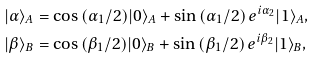Convert formula to latex. <formula><loc_0><loc_0><loc_500><loc_500>& | \alpha \rangle _ { A } = \cos { ( \alpha _ { 1 } / 2 ) } | 0 \rangle _ { A } + \sin { ( \alpha _ { 1 } / 2 ) } \, e ^ { i \alpha _ { 2 } } | 1 \rangle _ { A } , \\ & | \beta \rangle _ { B } = \cos { ( \beta _ { 1 } / 2 ) } | 0 \rangle _ { B } + \sin { ( \beta _ { 1 } / 2 ) } \, e ^ { i \beta _ { 2 } } | 1 \rangle _ { B } ,</formula> 